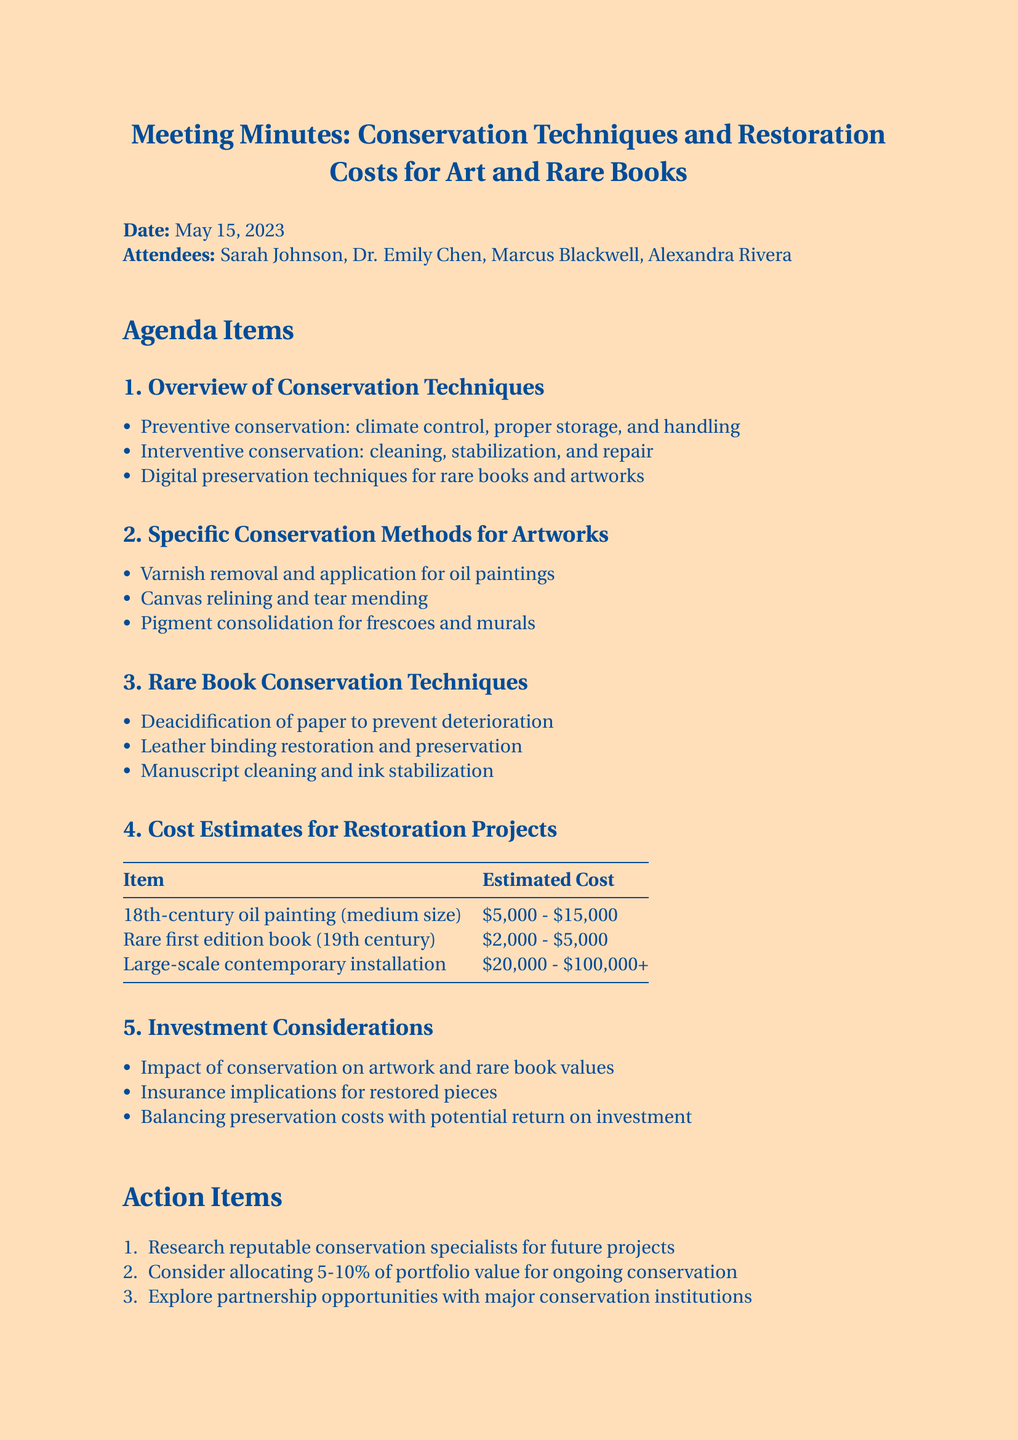What is the date of the meeting? The date mentioned in the document is May 15, 2023.
Answer: May 15, 2023 Who is the conservation specialist from the Getty Conservation Institute? The document lists Dr. Emily Chen as the conservation specialist from the Getty Conservation Institute.
Answer: Dr. Emily Chen What is one example of preventive conservation? The document states that climate control is one of the preventive conservation techniques.
Answer: Climate control What is the estimated cost range for an 18th-century oil painting? The estimated cost range provided in the document is between $5,000 and $15,000.
Answer: $5,000 - $15,000 What are two specific conservation methods for artworks? The document mentions varnish removal and canvas relining as specific conservation methods for artworks.
Answer: Varnish removal, canvas relining What impact does conservation have on artwork values? The document notes the importance of understanding the impact of conservation on artwork and rare book values.
Answer: Impact on values How much of the portfolio value is suggested for ongoing conservation? The action items suggest allocating 5-10% of portfolio value for ongoing conservation.
Answer: 5-10% What type of document is this? The structure and content indicate that this document is meeting minutes discussing conservation techniques and restoration costs.
Answer: Meeting minutes 